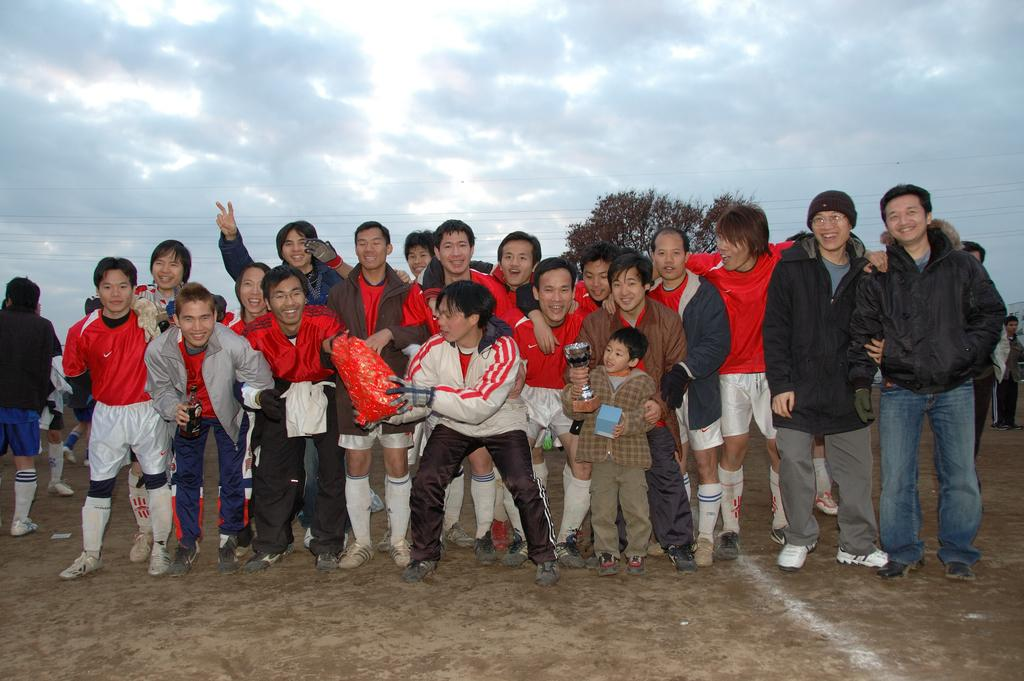How many people are in the image? There is a group of people in the image, but the exact number is not specified. What is the position of the people in the image? The people are standing on the ground in the image. What are some people holding in the image? Some people are holding objects in the image. What can be seen in the background of the image? There is a tree and the sky visible in the background of the image. What is the condition of the sky in the image? Clouds are present in the sky in the image. What type of twig is being used to give haircuts in the image? There is no twig or haircuts present in the image. Can you tell me how many airplanes are flying in the sky in the image? There are no airplanes visible in the sky in the image. 